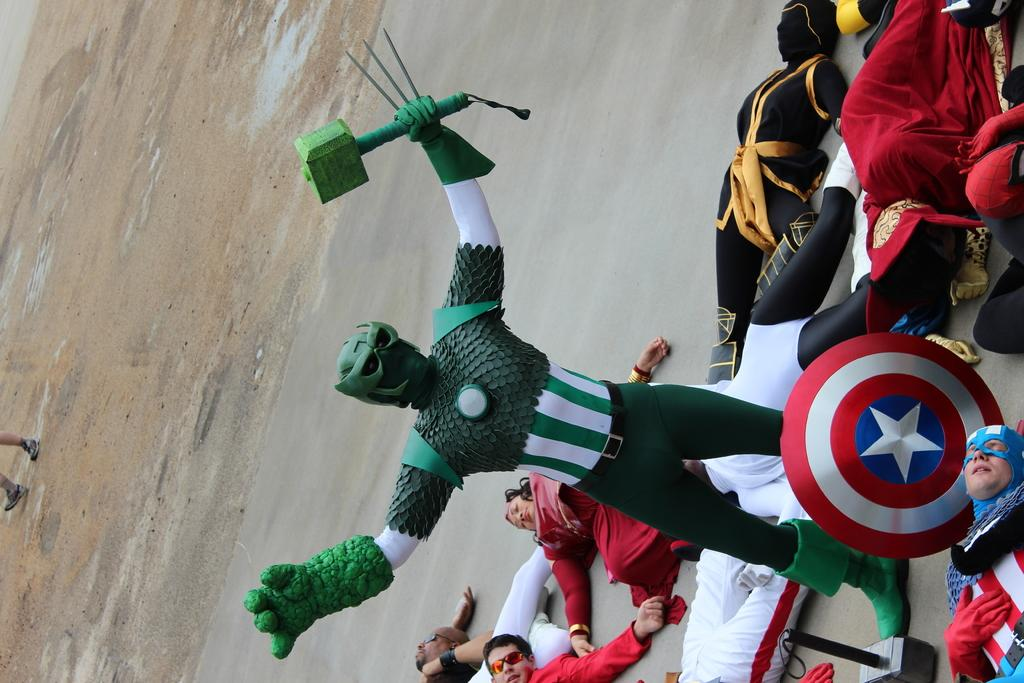How many people are in the group shown in the image? There is a group of people in the image, but the exact number is not specified. What are some people in the group wearing? Some people in the group are wearing costumes. What objects can be seen on the right side of the image? There is a shield and a hammer on the right side of the image. What type of front is visible in the image? There is no specific "front" mentioned or visible in the image. --- 